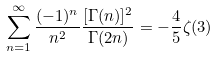<formula> <loc_0><loc_0><loc_500><loc_500>\sum _ { n = 1 } ^ { \infty } \frac { ( - 1 ) ^ { n } } { n ^ { 2 } } \frac { [ \Gamma ( n ) ] ^ { 2 } } { \Gamma ( 2 n ) } = - \frac { 4 } { 5 } \zeta ( 3 )</formula> 